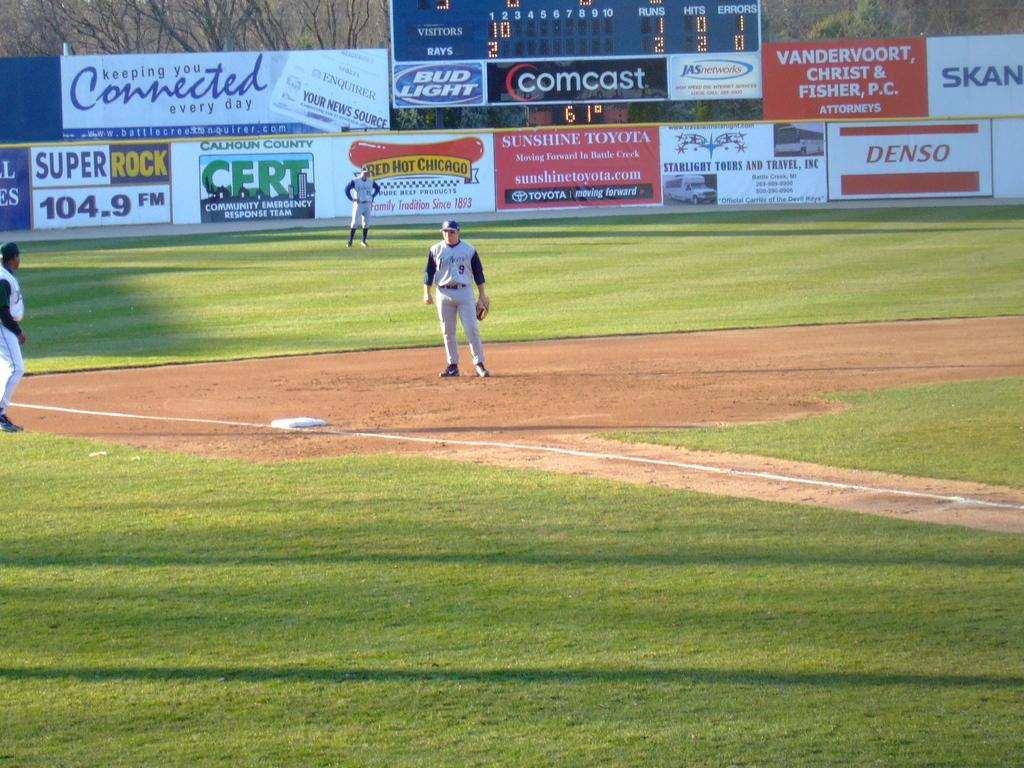<image>
Offer a succinct explanation of the picture presented. A baseball game is being played in a stadium that has a banner up for Comcast. 